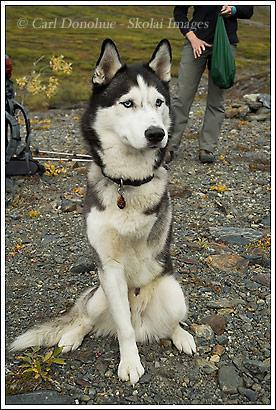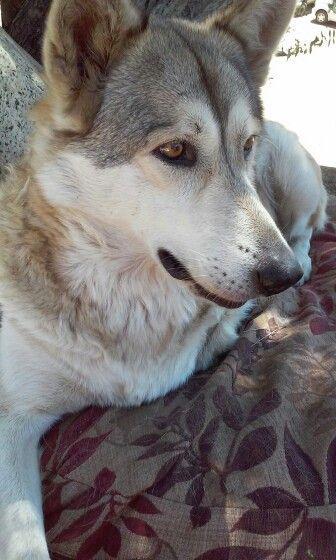The first image is the image on the left, the second image is the image on the right. Evaluate the accuracy of this statement regarding the images: "there are two huskies with their tongue sticking out in the image pair". Is it true? Answer yes or no. No. 